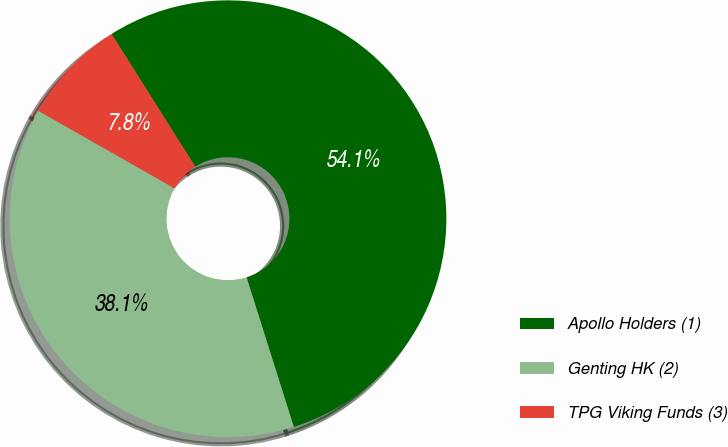Convert chart to OTSL. <chart><loc_0><loc_0><loc_500><loc_500><pie_chart><fcel>Apollo Holders (1)<fcel>Genting HK (2)<fcel>TPG Viking Funds (3)<nl><fcel>54.08%<fcel>38.1%<fcel>7.82%<nl></chart> 